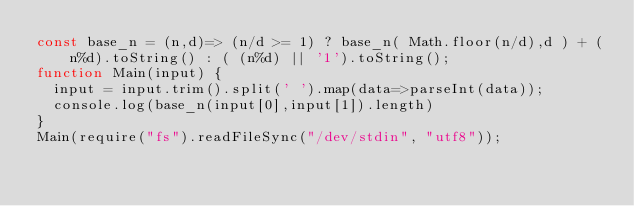Convert code to text. <code><loc_0><loc_0><loc_500><loc_500><_JavaScript_>const base_n = (n,d)=> (n/d >= 1) ? base_n( Math.floor(n/d),d ) + (n%d).toString() : ( (n%d) || '1').toString();
function Main(input) {
  input = input.trim().split(' ').map(data=>parseInt(data));
  console.log(base_n(input[0],input[1]).length)
}
Main(require("fs").readFileSync("/dev/stdin", "utf8"));</code> 